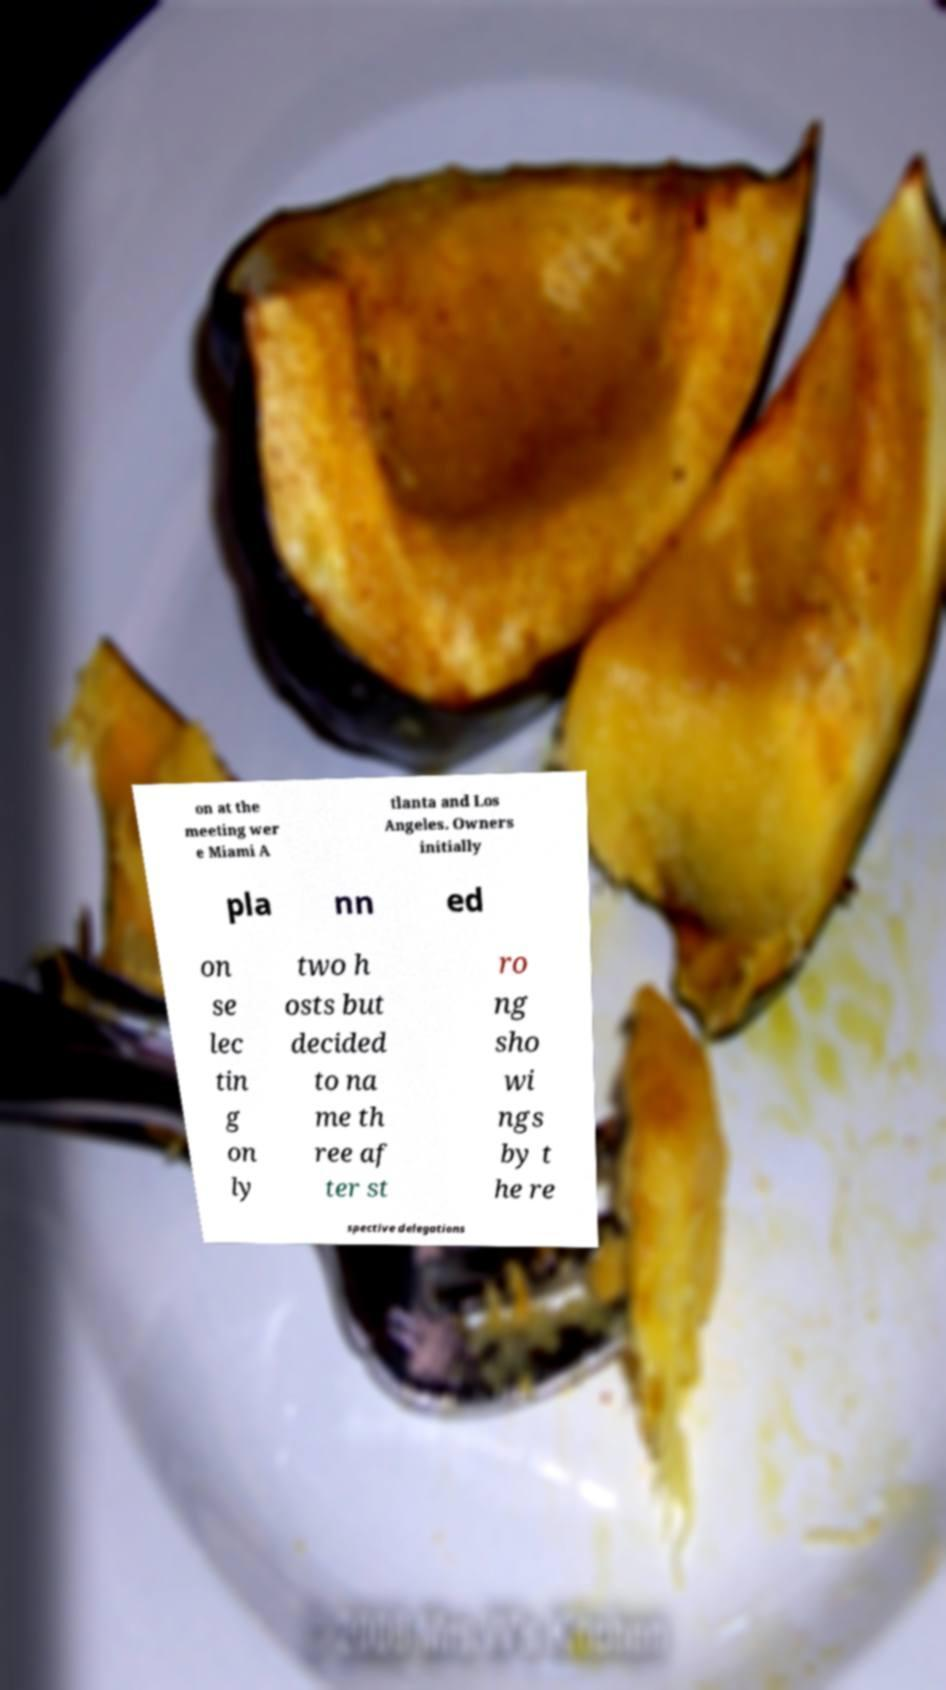What messages or text are displayed in this image? I need them in a readable, typed format. on at the meeting wer e Miami A tlanta and Los Angeles. Owners initially pla nn ed on se lec tin g on ly two h osts but decided to na me th ree af ter st ro ng sho wi ngs by t he re spective delegations 